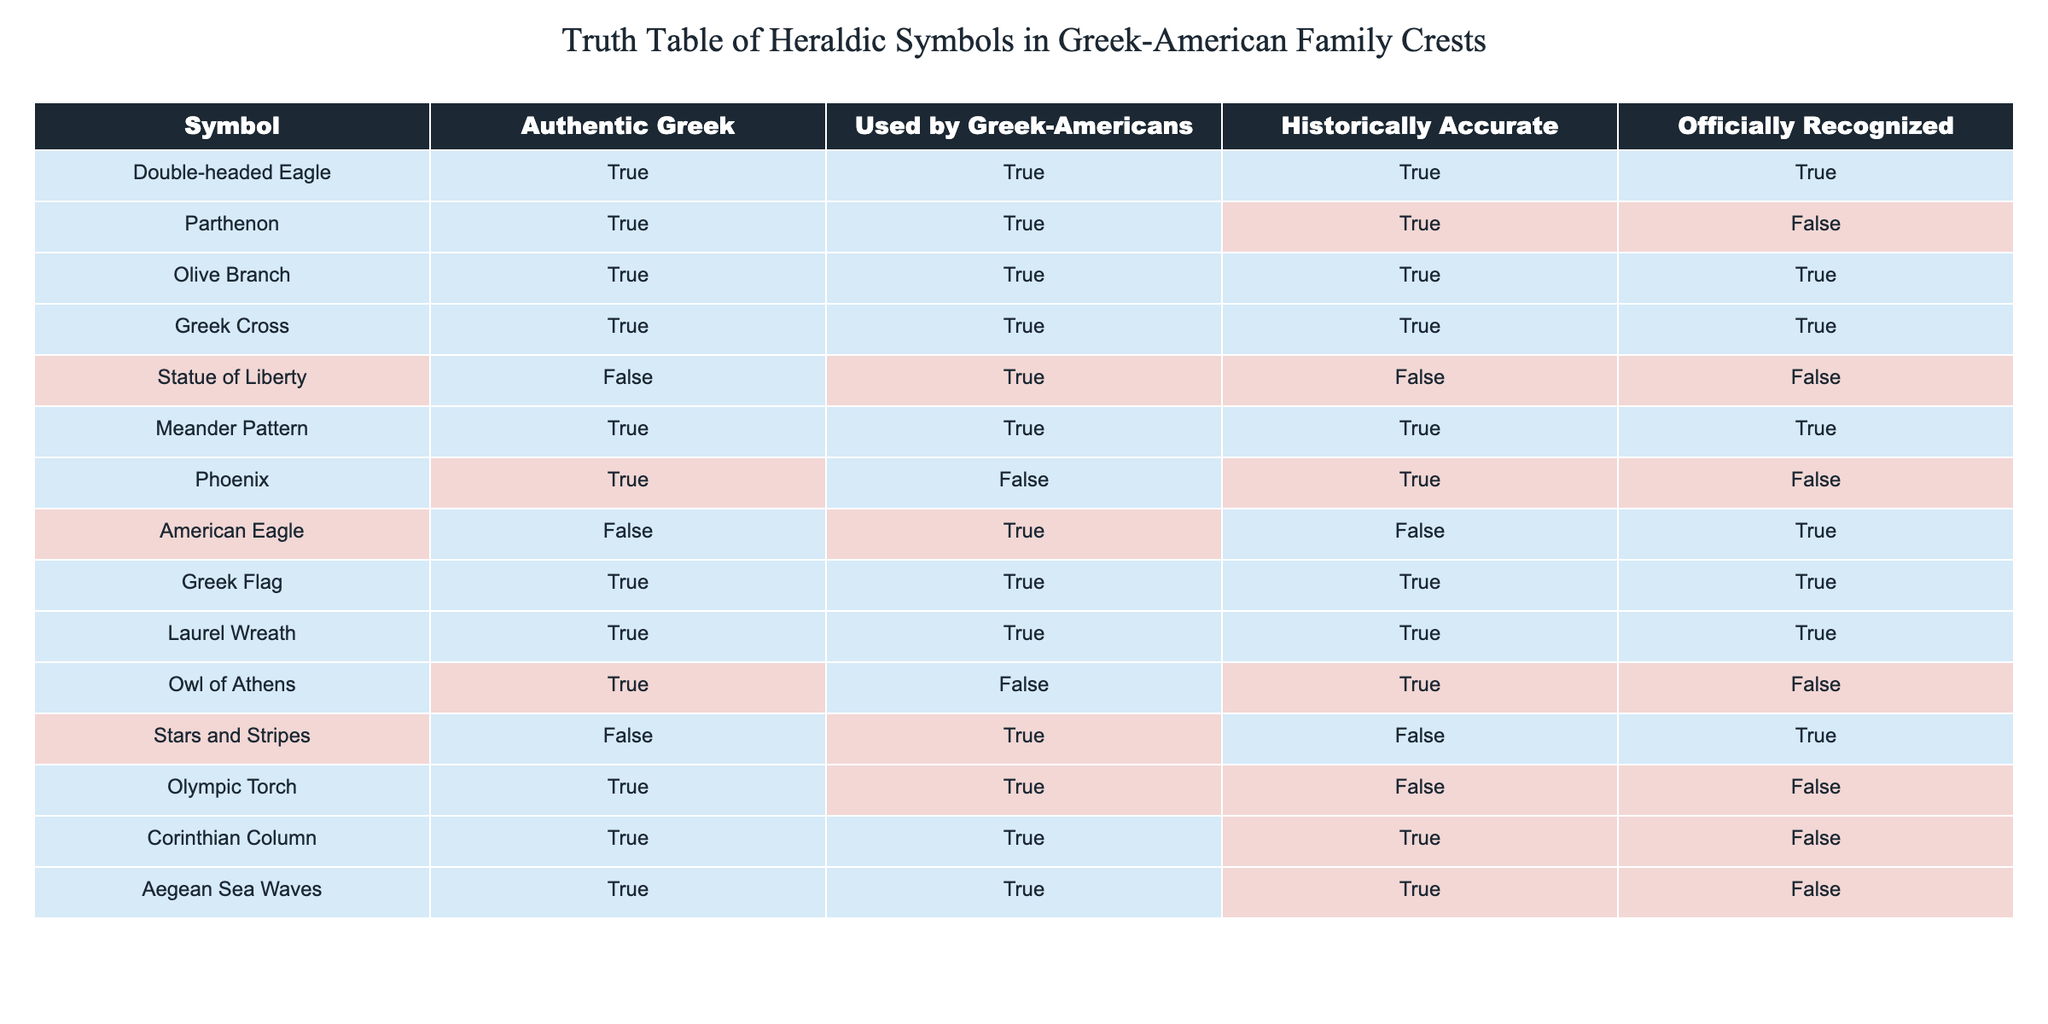What symbols are officially recognized in Greek-American family crests? To answer this, we look at the "Officially Recognized" column for each symbol. The symbols that have a value of TRUE in this column are the Double-headed Eagle, Greek Cross, Greek Flag, Laurel Wreath, and Meander Pattern.
Answer: Double-headed Eagle, Greek Cross, Greek Flag, Laurel Wreath, Meander Pattern Which symbol is historically accurate but not used by Greek-Americans? We need to find a symbol with a value of TRUE in the "Historically Accurate" column and FALSE in the "Used by Greek-Americans" column. The only symbol that meets this criterion is the Phoenix.
Answer: Phoenix How many heraldic symbols are both authentic Greek and used by Greek-Americans? We count the symbols that have a value of TRUE in both the "Authentic Greek" and "Used by Greek-Americans" columns. This includes Double-headed Eagle, Parthenon, Olive Branch, Greek Cross, Meander Pattern, Greek Flag, and Laurel Wreath, totaling 7 symbols.
Answer: 7 Is the Statue of Liberty an officially recognized symbol in Greek-American heraldry? We check the value in the "Officially Recognized" column for the Statue of Liberty. It shows a value of FALSE, indicating that it is not recognized as an official symbol among Greek-Americans.
Answer: No Which symbol has historical accuracy but is not officially recognized? Searching for a symbol that has a TRUE value in the "Historically Accurate" column while having a FALSE value in the "Officially Recognized" column leads us to the Parthenon and the Olympic Torch.
Answer: Parthenon, Olympic Torch Are there any symbols that are both not authentic Greek and used by Greek-Americans? We look for symbols with FALSE values in the "Authentic Greek" column and TRUE in the "Used by Greek-Americans" column. The American Eagle, Statue of Liberty, and Stars and Stripes fit this criterion.
Answer: American Eagle, Statue of Liberty, Stars and Stripes How many symbols are historically accurate and officially recognized? We need to count the symbols that have TRUE in both the "Historically Accurate" and "Officially Recognized" columns. These symbols are the Double-headed Eagle, Greek Cross, and Greek Flag, totaling 3 symbols.
Answer: 3 Which heraldic symbol has artistic value but lacks historical accuracy? We find a symbol that has TRUE in "Used by Greek-Americans" and FALSE in "Historically Accurate." The Olympic Torch fits this requirement.
Answer: Olympic Torch 